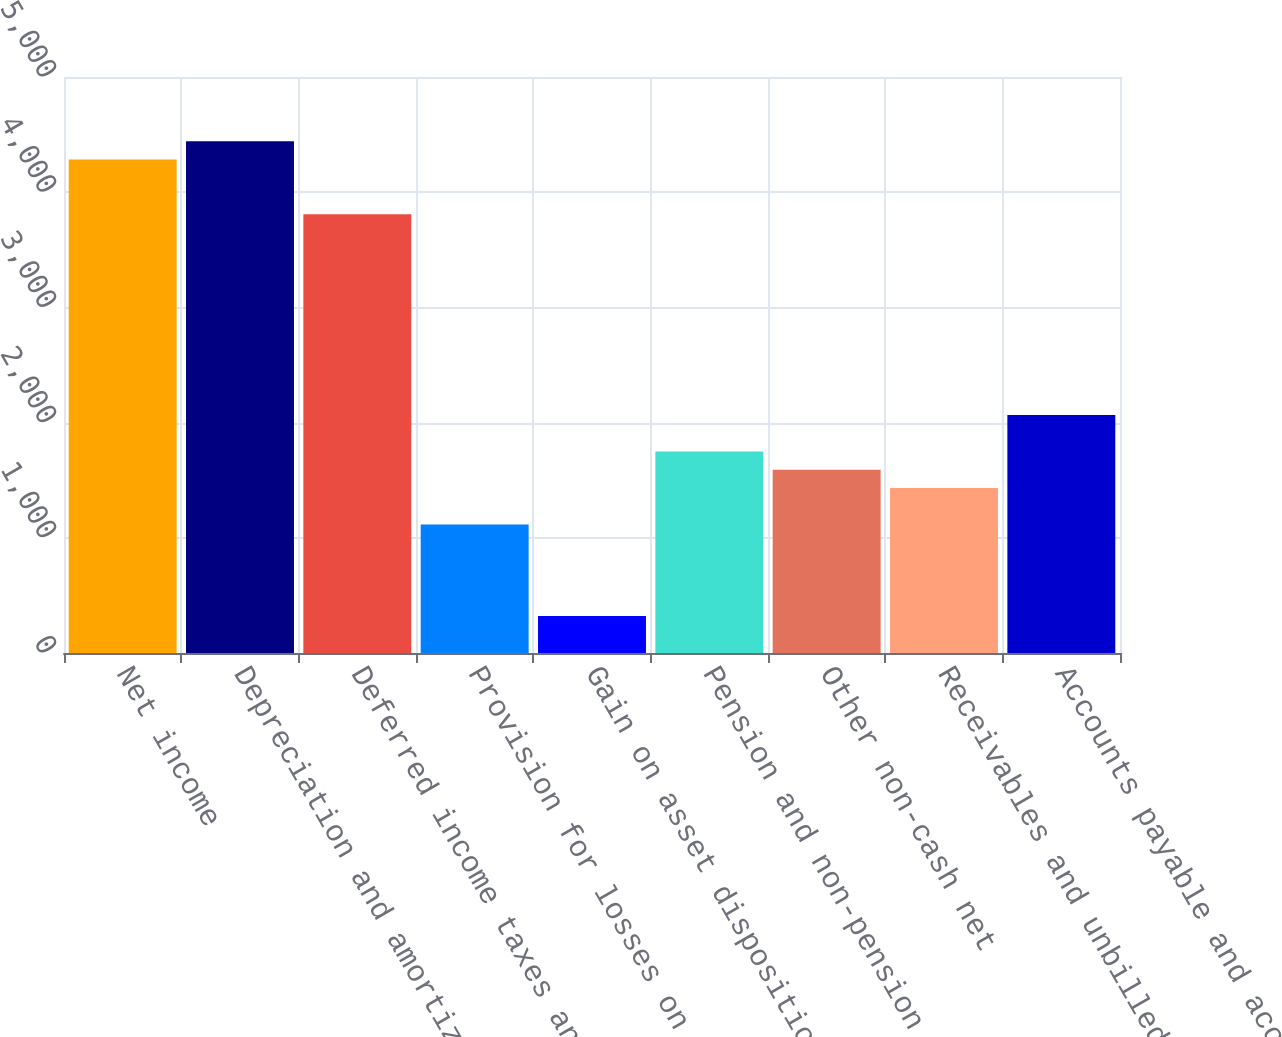Convert chart to OTSL. <chart><loc_0><loc_0><loc_500><loc_500><bar_chart><fcel>Net income<fcel>Depreciation and amortization<fcel>Deferred income taxes and<fcel>Provision for losses on<fcel>Gain on asset dispositions and<fcel>Pension and non-pension<fcel>Other non-cash net<fcel>Receivables and unbilled<fcel>Accounts payable and accrued<nl><fcel>4284.5<fcel>4443<fcel>3809<fcel>1114.5<fcel>322<fcel>1748.5<fcel>1590<fcel>1431.5<fcel>2065.5<nl></chart> 